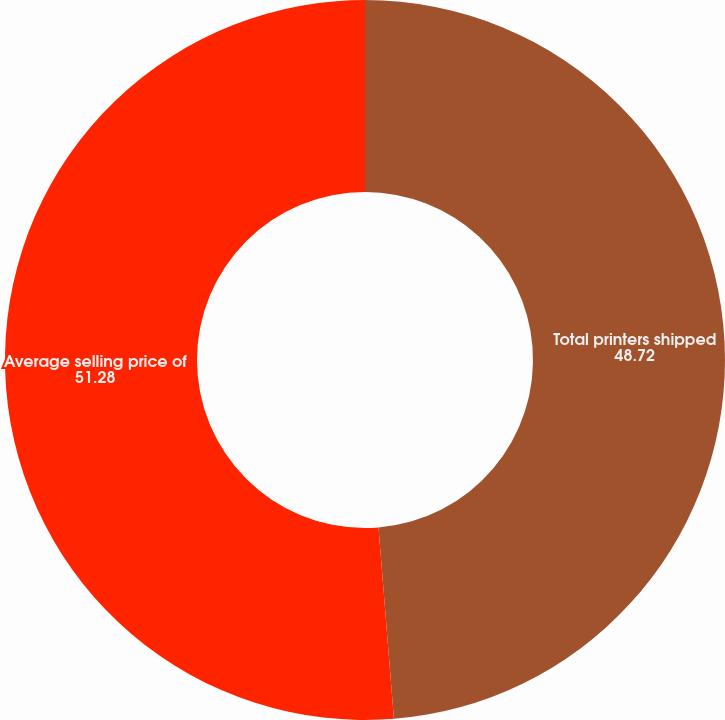Convert chart to OTSL. <chart><loc_0><loc_0><loc_500><loc_500><pie_chart><fcel>Total printers shipped<fcel>Average selling price of<nl><fcel>48.72%<fcel>51.28%<nl></chart> 